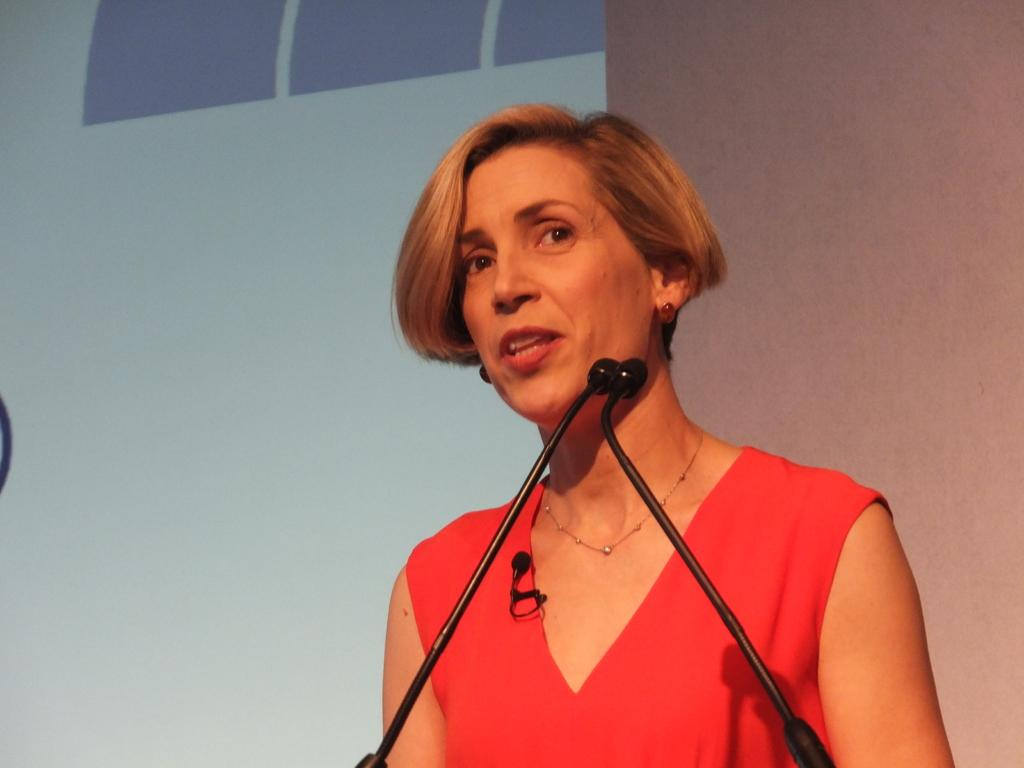Who is the main subject in the image? There is a woman in the image. What is the woman wearing on her upper body? The woman is wearing a red top. Are there any accessories visible on the woman? Yes, the woman is wearing jewelry. What is in front of the woman in the image? There are mics in front of the woman. What can be seen in the background of the image? There is a wall and a screen in the background of the image. What type of jar is visible on the screen in the background? There is no jar visible on the screen in the background; it is a screen with an unspecified image or content. 